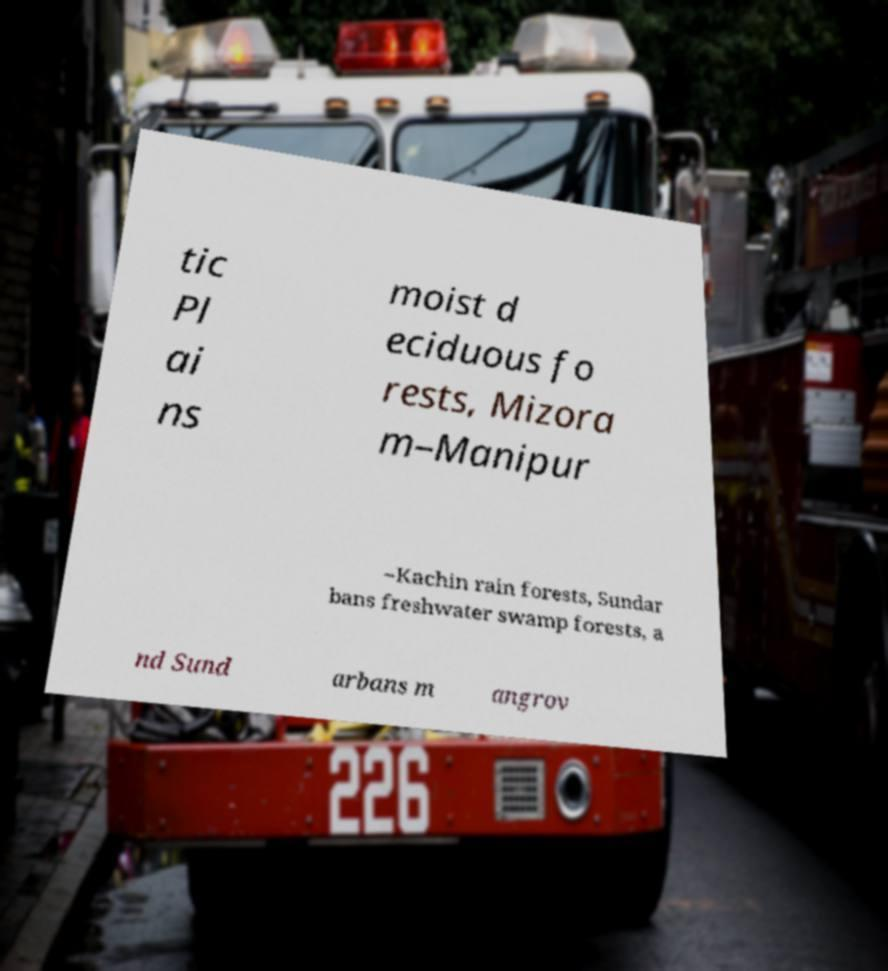Could you assist in decoding the text presented in this image and type it out clearly? tic Pl ai ns moist d eciduous fo rests, Mizora m–Manipur –Kachin rain forests, Sundar bans freshwater swamp forests, a nd Sund arbans m angrov 